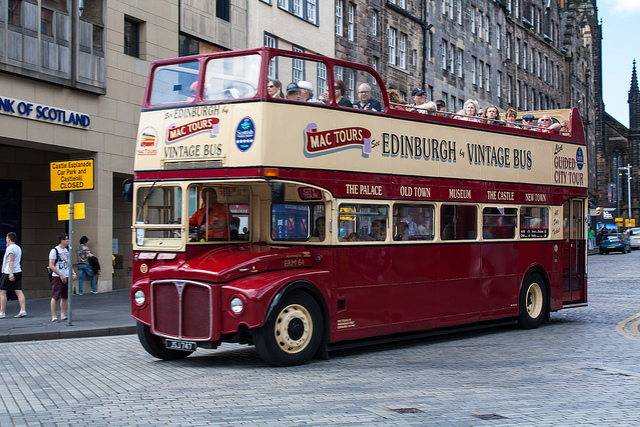<image>What is the woman's name on the bus? It is unknown what the woman's name on the bus is. What fantasy movie has a magic bus similar to this one? I am not sure which fantasy movie has a magic bus similar to this one. It can be 'Harry Potter' or 'Magic School Bus'. What is the woman's name on the bus? I don't know the name of the woman on the bus. It can be either Edin, Mac, Jen, Debra, Sally, Lisa, or Carol. What fantasy movie has a magic bus similar to this one? I am not sure which fantasy movie has a magic bus similar to this one. It can be 'harry potter' or 'magic school bus'. 